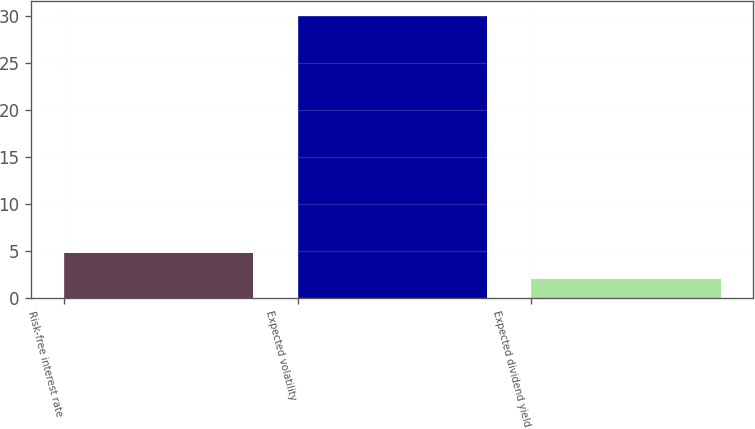Convert chart to OTSL. <chart><loc_0><loc_0><loc_500><loc_500><bar_chart><fcel>Risk-free interest rate<fcel>Expected volatility<fcel>Expected dividend yield<nl><fcel>4.85<fcel>30<fcel>2.06<nl></chart> 